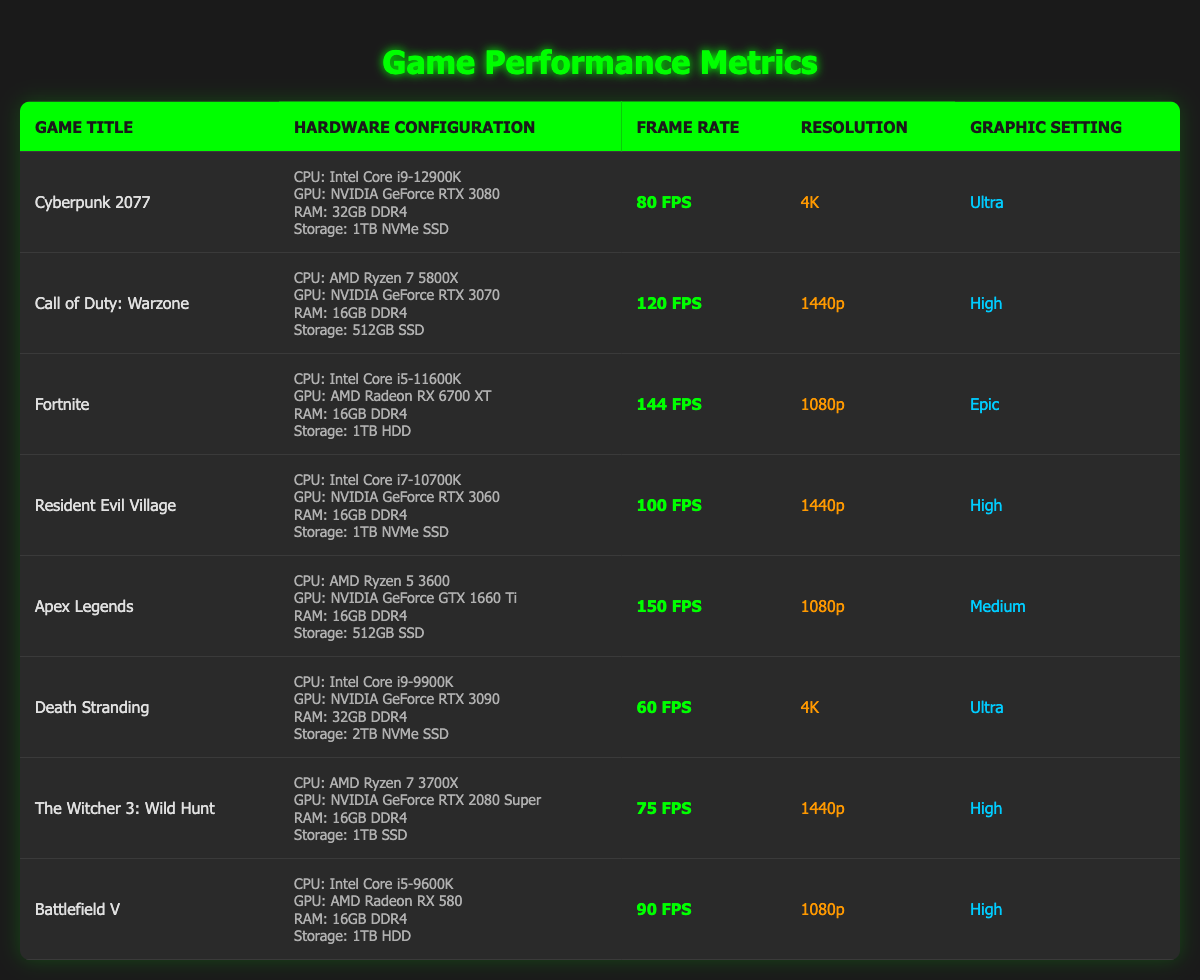What is the frame rate of Apex Legends? The frame rate of Apex Legends is listed in the table provided, which shows "150 FPS" in the corresponding row.
Answer: 150 FPS Which game has the highest frame rate? By inspecting the frame rates of all games in the table, Apex Legends has the highest frame rate at "150 FPS".
Answer: Apex Legends Is the graphic setting for Cyberpunk 2077 set to Ultra? The table lists the graphic setting for Cyberpunk 2077 as "Ultra", confirming that it is true.
Answer: Yes What is the average frame rate of the games listed? Adding the frame rates together (80 + 120 + 144 + 100 + 150 + 60 + 75 + 90) gives a total of 819 FPS. There are 8 games, so the average frame rate is 819 / 8 = 102.375 FPS.
Answer: 102.375 FPS Does Resident Evil Village have a higher frame rate than Battlefield V? The frame rate for Resident Evil Village is "100 FPS" and for Battlefield V, it is "90 FPS". Since 100 is greater than 90, Resident Evil Village does have a higher frame rate.
Answer: Yes What resolution does Death Stranding run at? The resolution for Death Stranding is displayed in the table as "4K".
Answer: 4K How many games were tested at 1440p resolution? By examining the resolution column, Call of Duty: Warzone and Resident Evil Village are both listed as "1440p", totaling 2 games.
Answer: 2 games Which game has the lowest frame rate, and what is its graphical setting? Checking the frame rates, Death Stranding has the lowest at "60 FPS" with a graphical setting of "Ultra".
Answer: Death Stranding, Ultra What is the difference in frame rates between Fortnite and Call of Duty: Warzone? Fortnite has a frame rate of "144 FPS" and Call of Duty: Warzone has "120 FPS". The difference is calculated as 144 - 120 = 24 FPS.
Answer: 24 FPS 